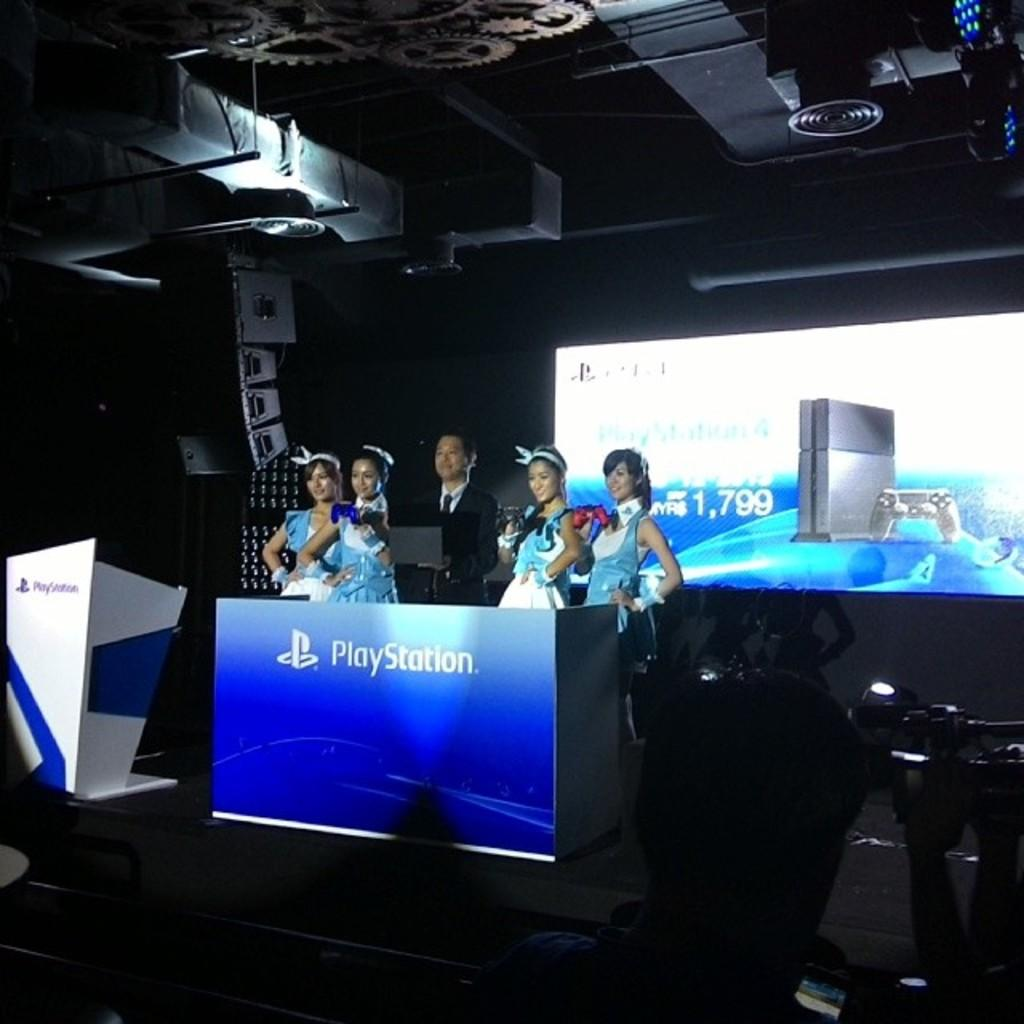What is happening on the stage in the image? There are people standing on the stage in the image. What object can be seen near the people on the stage? The people are near a podium. What is written on the podium? The word "Playstation" is written on the podium. What is present on the wall behind the stage? There is a projector screen on the wall behind the stage. Can you tell me how many cars are parked on the stage in the image? There are no cars present on the stage in the image. What type of spot is visible on the podium in the image? There is no spot visible on the podium in the image. 